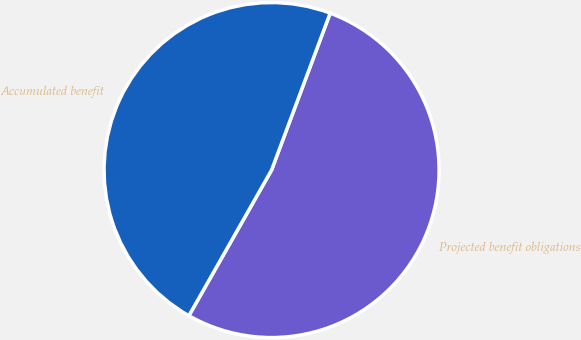<chart> <loc_0><loc_0><loc_500><loc_500><pie_chart><fcel>Projected benefit obligations<fcel>Accumulated benefit<nl><fcel>52.53%<fcel>47.47%<nl></chart> 